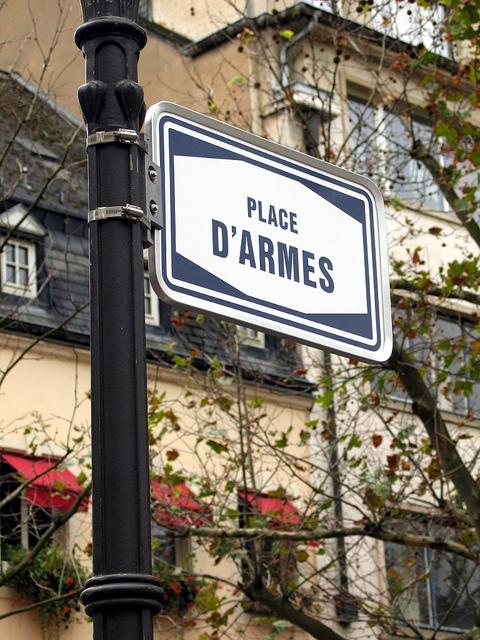What shape is the sign?
Write a very short answer. Rectangle. What is on the sign?
Concise answer only. Place d'armes. Is this a sign you can read?
Keep it brief. Yes. 